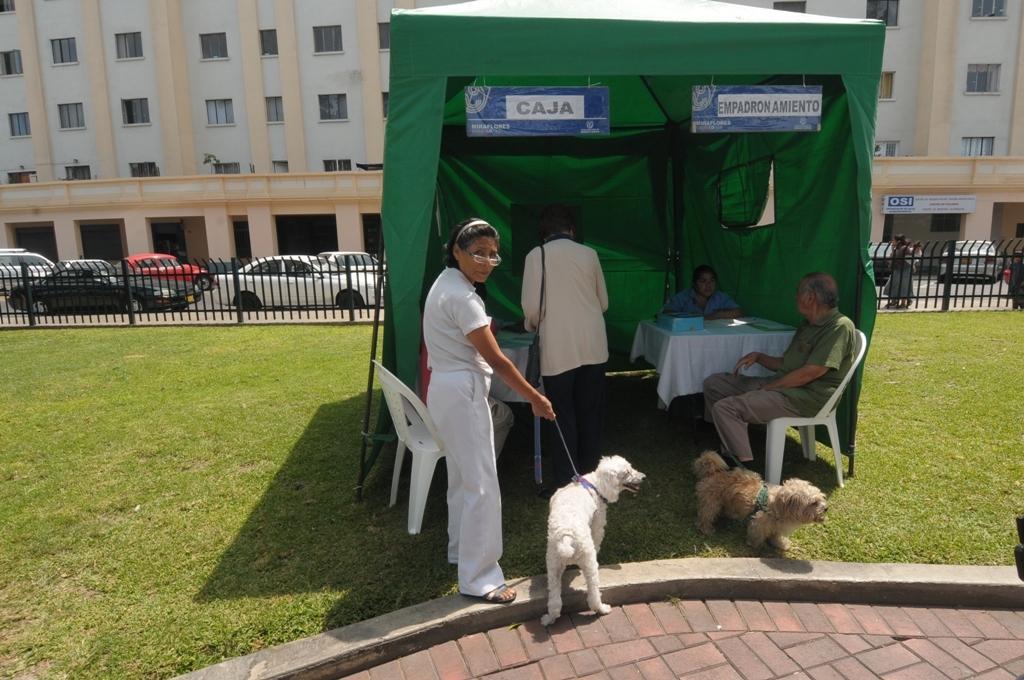In one or two sentences, can you explain what this image depicts? In this image there is a tent in the middle. Inside the tent there are two tables. At the bottom there is a woman who is holding the dog. Beside the woman there is a person sitting in the chair. Beside him there is a dog. At the top of the text there are two boards. In the background there is fence. In the background there are buildings. In front of the buildings there are cars parked on the road. 